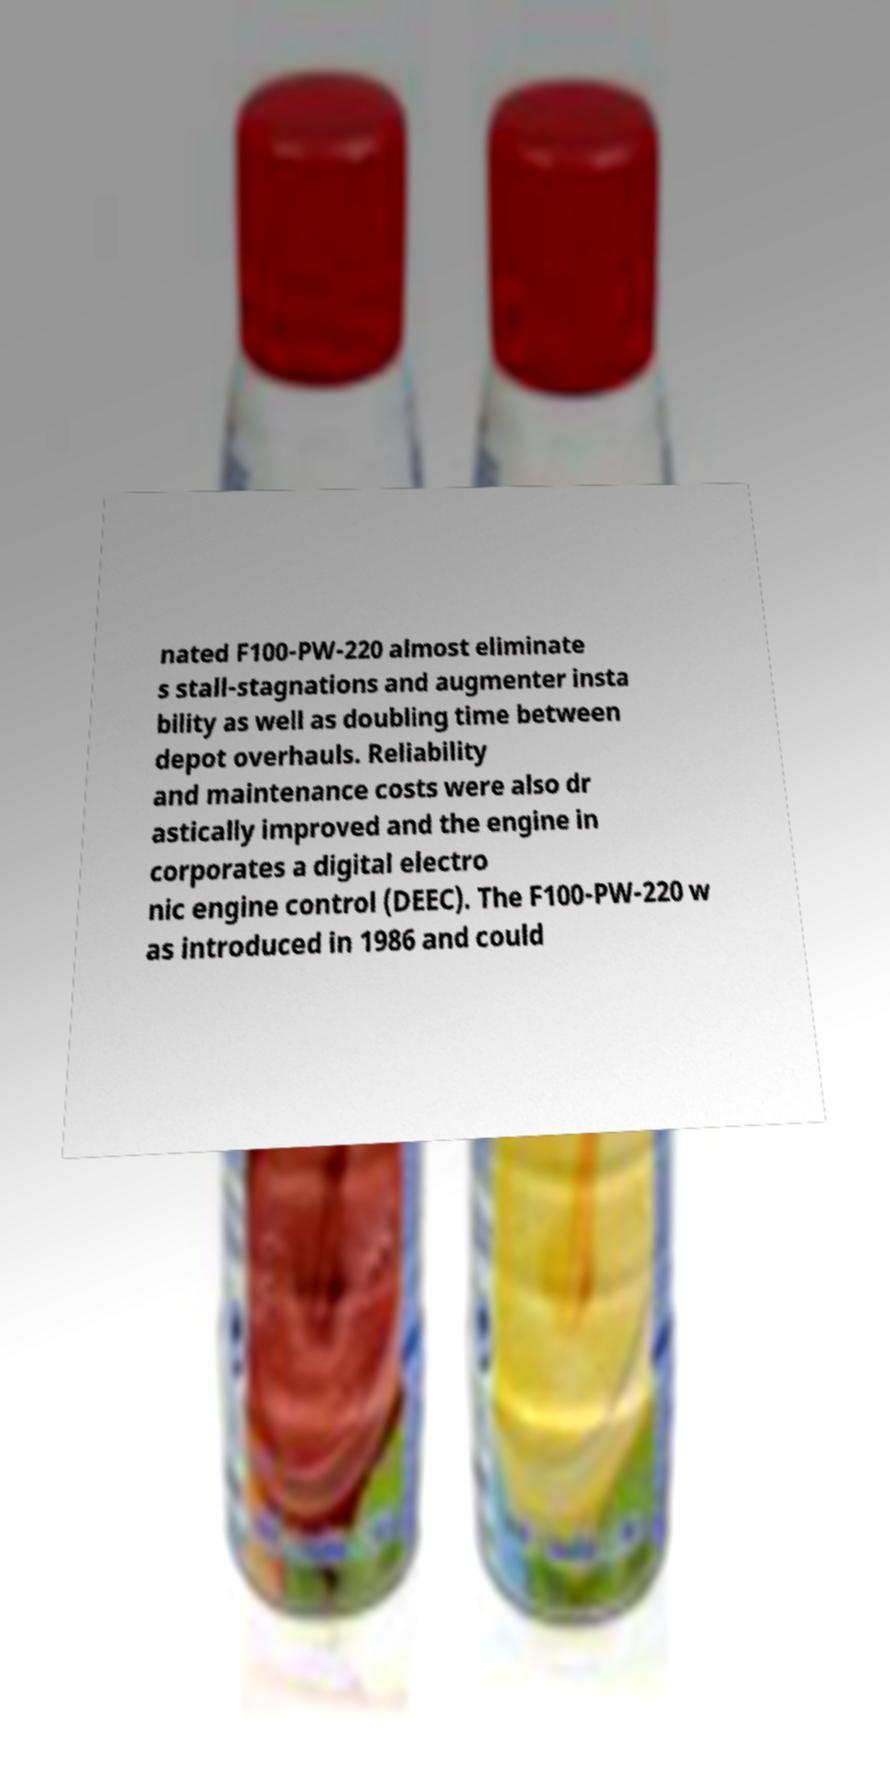I need the written content from this picture converted into text. Can you do that? nated F100-PW-220 almost eliminate s stall-stagnations and augmenter insta bility as well as doubling time between depot overhauls. Reliability and maintenance costs were also dr astically improved and the engine in corporates a digital electro nic engine control (DEEC). The F100-PW-220 w as introduced in 1986 and could 